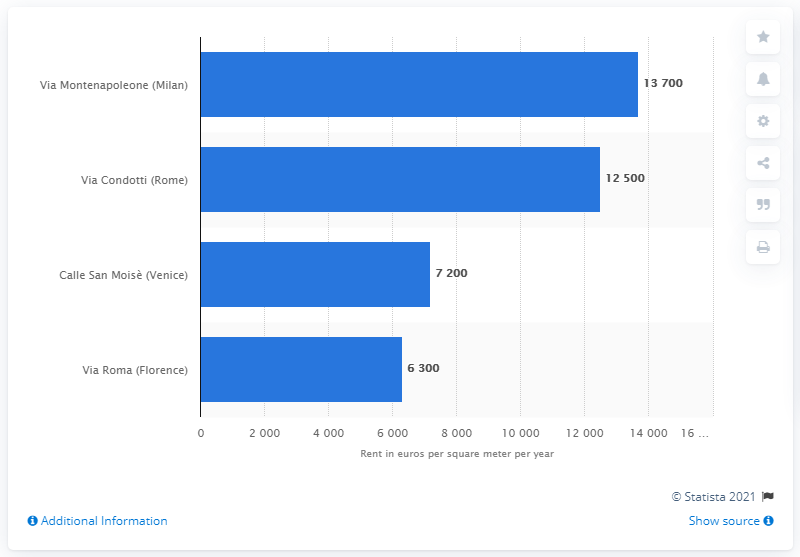Specify some key components in this picture. The average yearly rent in the Milanese luxury shopping street was 13,700 euro in 1370. 